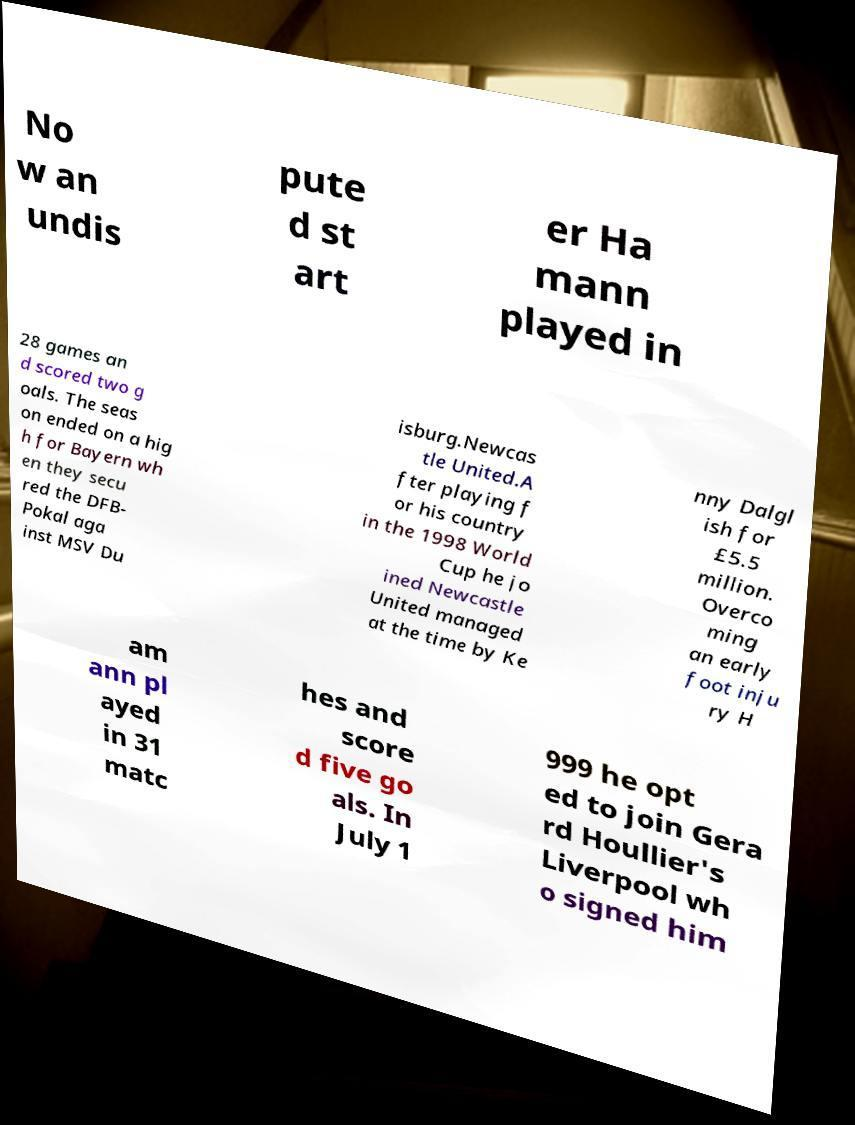Please read and relay the text visible in this image. What does it say? No w an undis pute d st art er Ha mann played in 28 games an d scored two g oals. The seas on ended on a hig h for Bayern wh en they secu red the DFB- Pokal aga inst MSV Du isburg.Newcas tle United.A fter playing f or his country in the 1998 World Cup he jo ined Newcastle United managed at the time by Ke nny Dalgl ish for £5.5 million. Overco ming an early foot inju ry H am ann pl ayed in 31 matc hes and score d five go als. In July 1 999 he opt ed to join Gera rd Houllier's Liverpool wh o signed him 